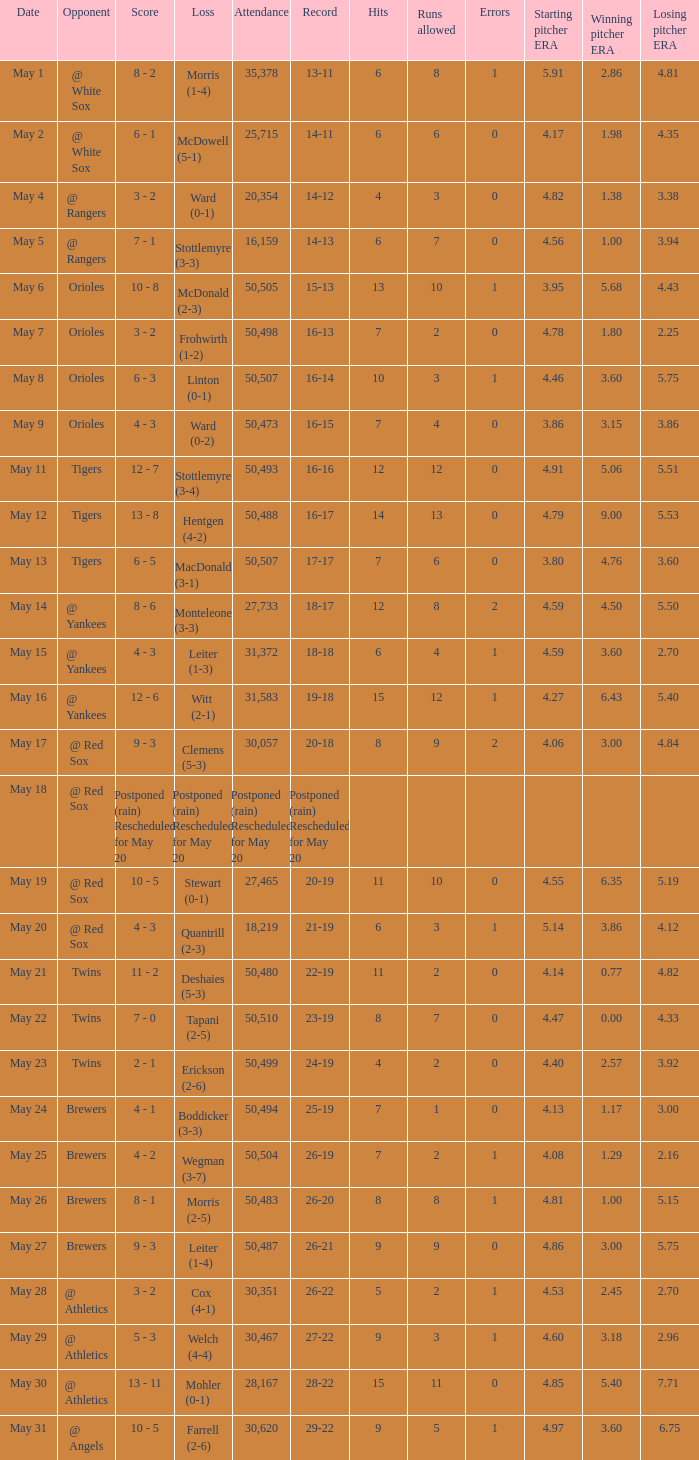What team did they lose to when they had a 28-22 record? Mohler (0-1). 